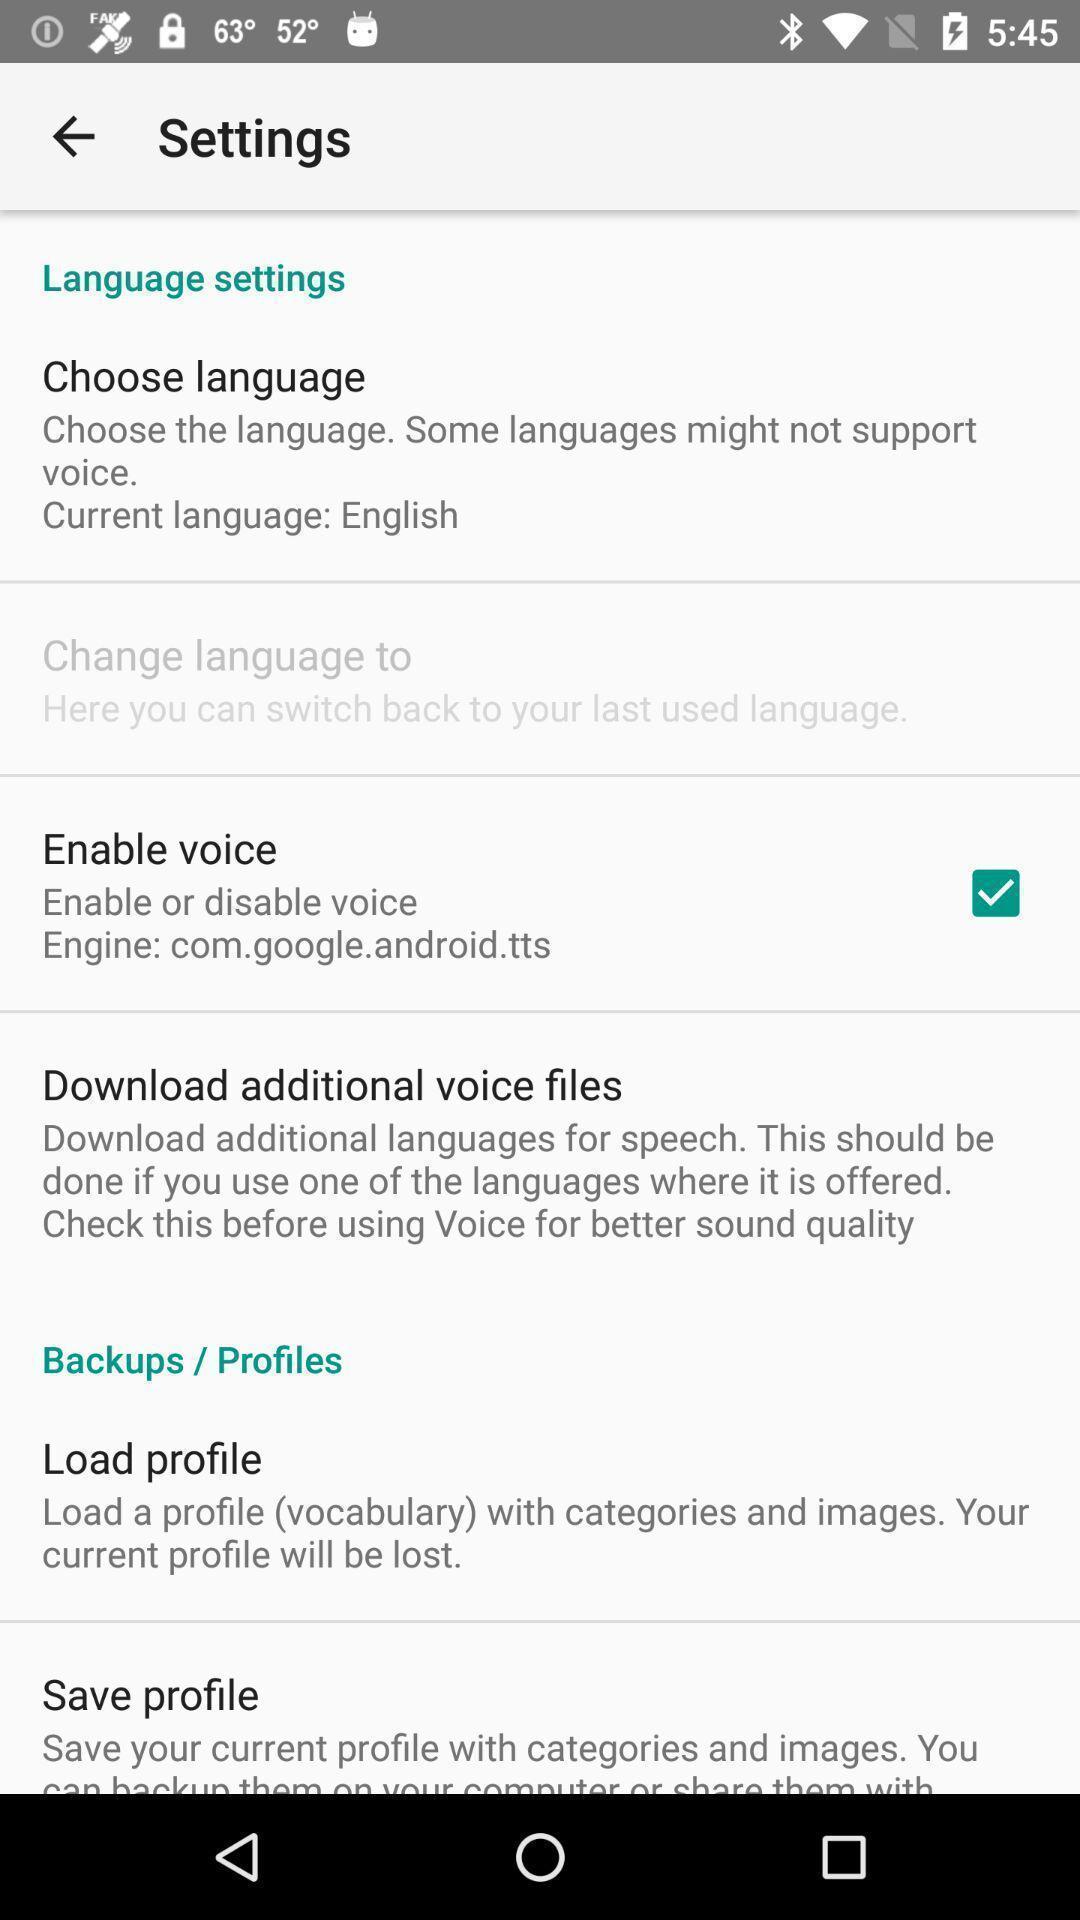Tell me about the visual elements in this screen capture. Screen shows few language settings. 